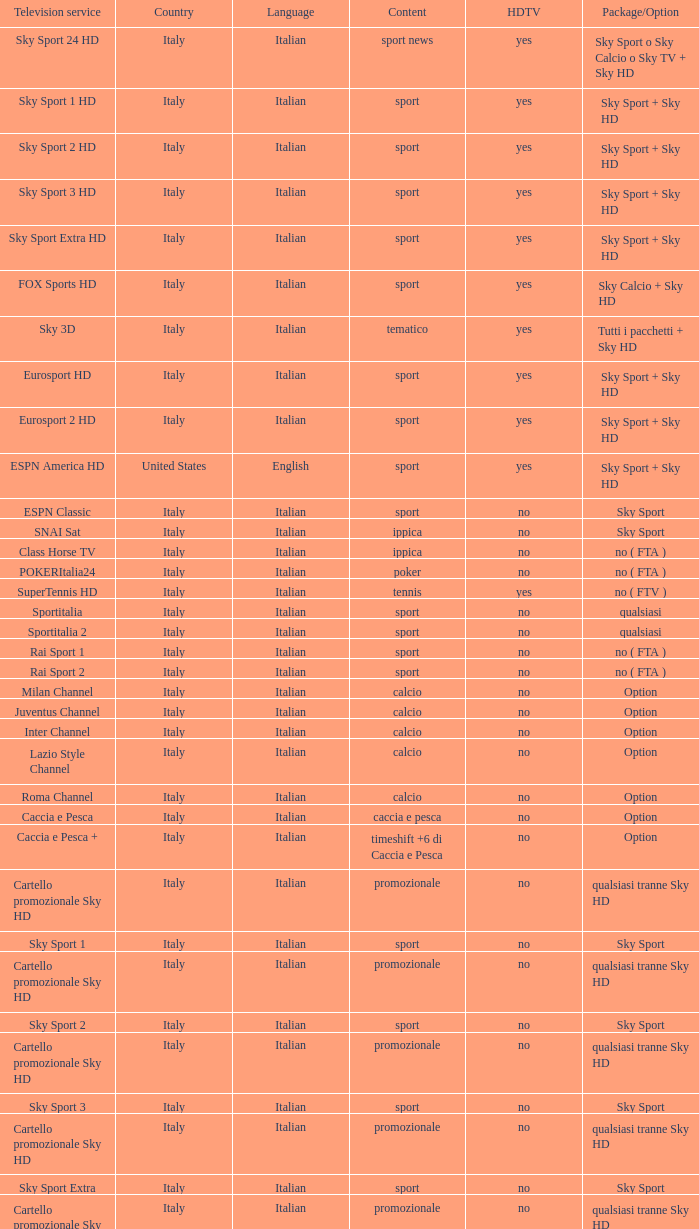What is Language, when Content is Sport, when HDTV is No, and when Television Service is ESPN America? Italian. 